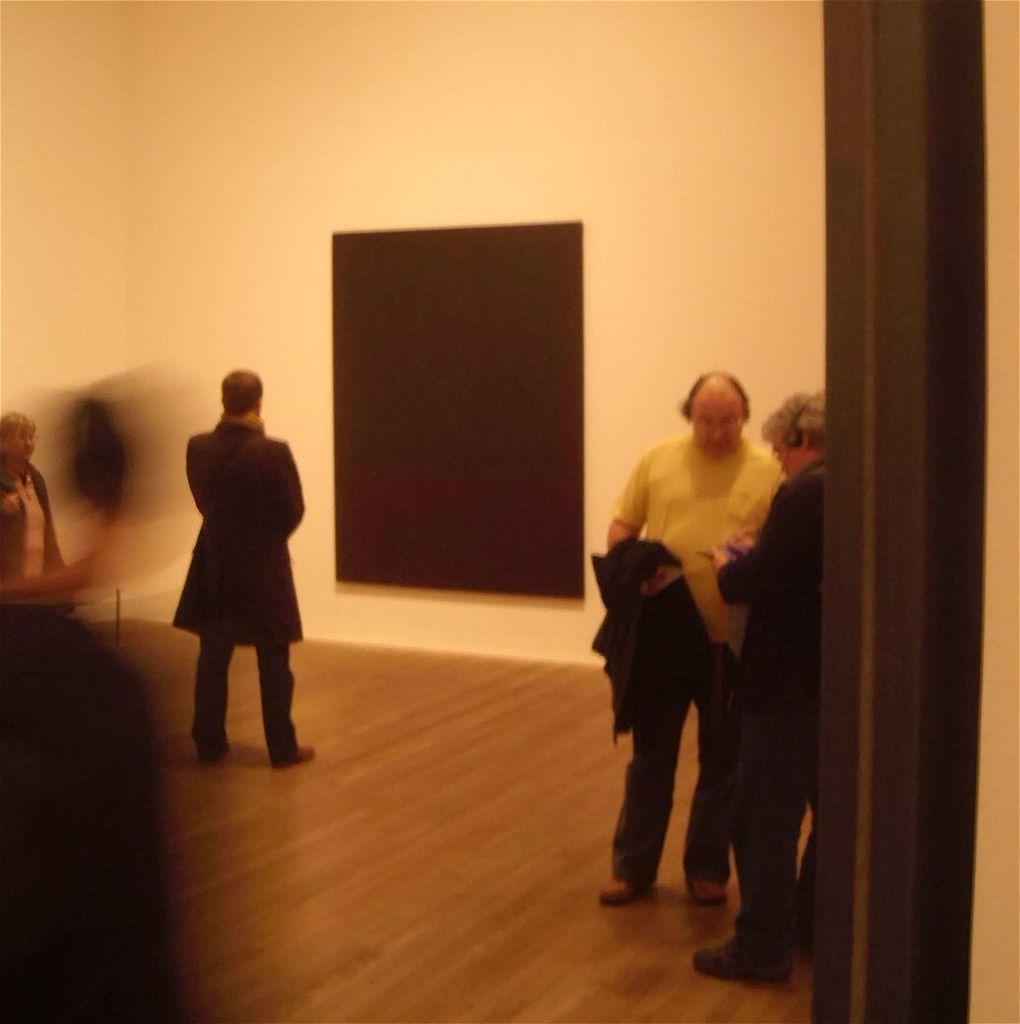Could you give a brief overview of what you see in this image? Here we can see four persons on the floor. In the background there is a black board and a wall. 